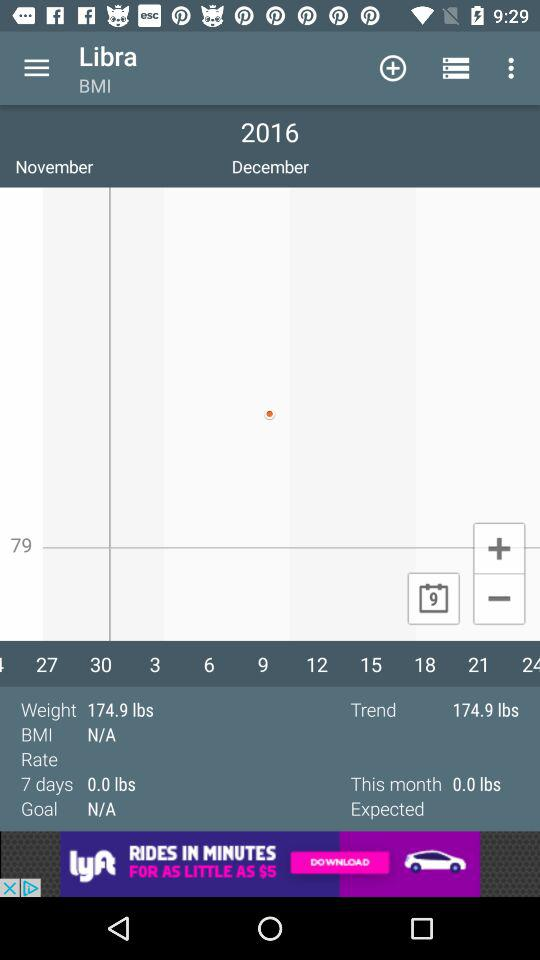What is the month? The months are November and December. 